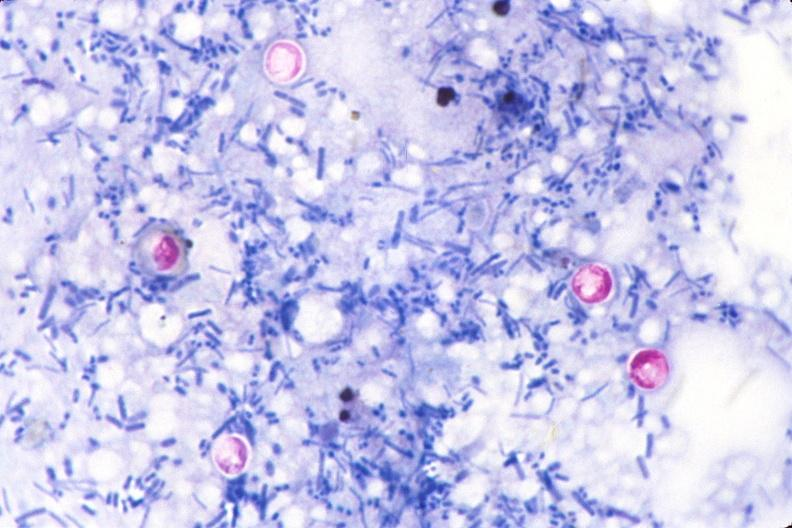does optic nerve show cryptosporidia, acid fast stain of feces?
Answer the question using a single word or phrase. No 